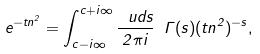<formula> <loc_0><loc_0><loc_500><loc_500>e ^ { - t { n } ^ { 2 } } = \int _ { c - i \infty } ^ { c + i \infty } \frac { \ u d s } { 2 \pi i } \ \Gamma ( s ) ( t { n } ^ { 2 } ) ^ { - s } ,</formula> 